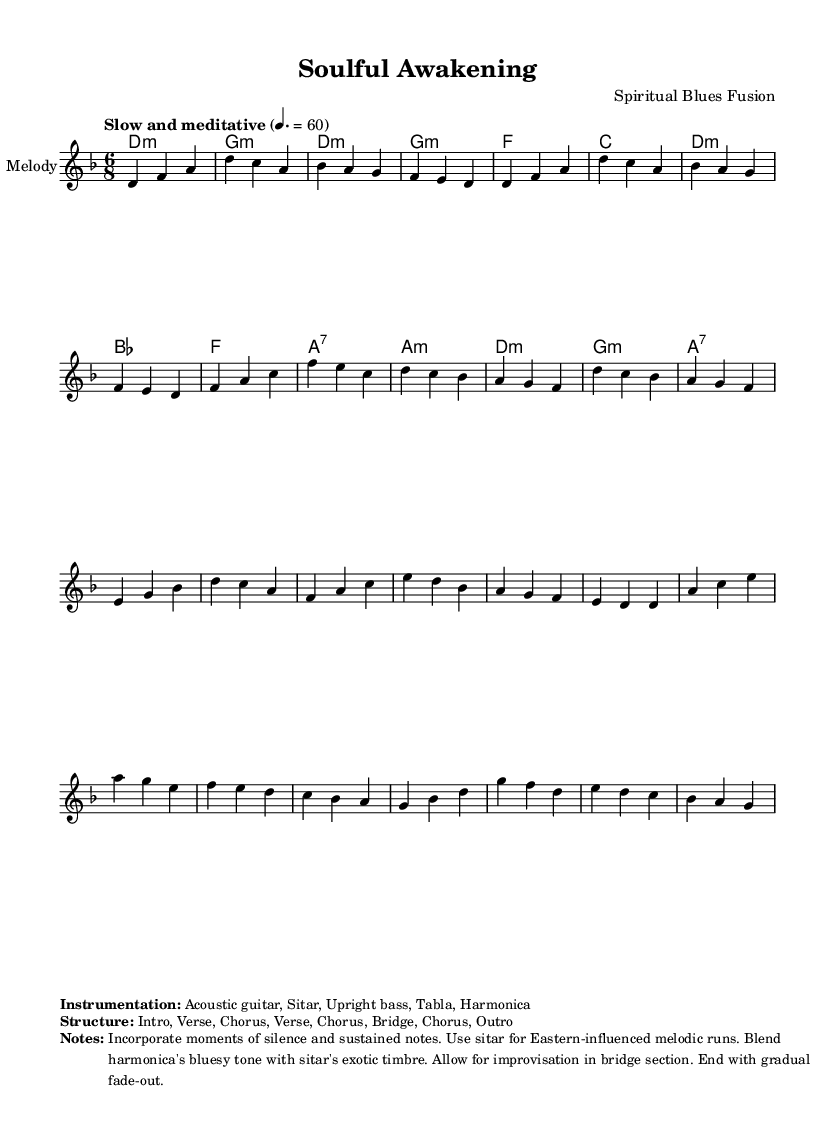What is the key signature of this music? The key signature is D minor, which has one flat (B flat) and indicates the tonal structure of the piece.
Answer: D minor What is the time signature of this piece? The time signature shows that each measure has six beats, with an emphasis on the division into groups of three beats consistent with a compound meter. This is reflected by the "6/8" notation.
Answer: 6/8 What is the tempo marking for this piece? The tempo marking indicates that the piece should be played slowly and meditatively at a pace of 60 beats per minute, which creates a reflective and soulful atmosphere.
Answer: Slow and meditative at 60 How many sections are in the structure of the piece? The structure includes a total of eight sections, comprising an intro, two verses, a chorus repeated three times, and a bridge. This indicates a well-defined format for the song.
Answer: Eight sections What instruments are featured in this composition? The piece incorporates acoustic guitar, sitar, upright bass, tabla, and harmonica, which collectively contribute to its fusion of blues and world music.
Answer: Acoustic guitar, Sitar, Upright bass, Tabla, Harmonica What is the primary musical style represented in this score? This score represents a fusion of blues with elements of spirituality and world music traditions, indicated through the use of diverse instruments and the meditative quality of the melody.
Answer: Spiritual blues fusion What should be highlighted in the bridge section of the piece? The bridge section allows for improvisation, showcasing the performers' creativity and expression, which is a common feature in blues music. This element is essential for adding depth to the performance.
Answer: Improvisation 